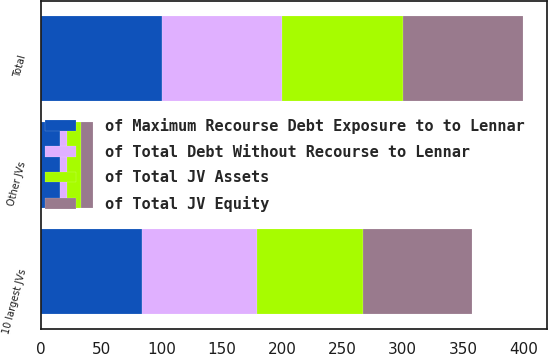<chart> <loc_0><loc_0><loc_500><loc_500><stacked_bar_chart><ecel><fcel>10 largest JVs<fcel>Other JVs<fcel>Total<nl><fcel>of Total JV Equity<fcel>90<fcel>10<fcel>100<nl><fcel>of Maximum Recourse Debt Exposure to to Lennar<fcel>84<fcel>16<fcel>100<nl><fcel>of Total Debt Without Recourse to Lennar<fcel>95<fcel>5<fcel>100<nl><fcel>of Total JV Assets<fcel>88<fcel>12<fcel>100<nl></chart> 